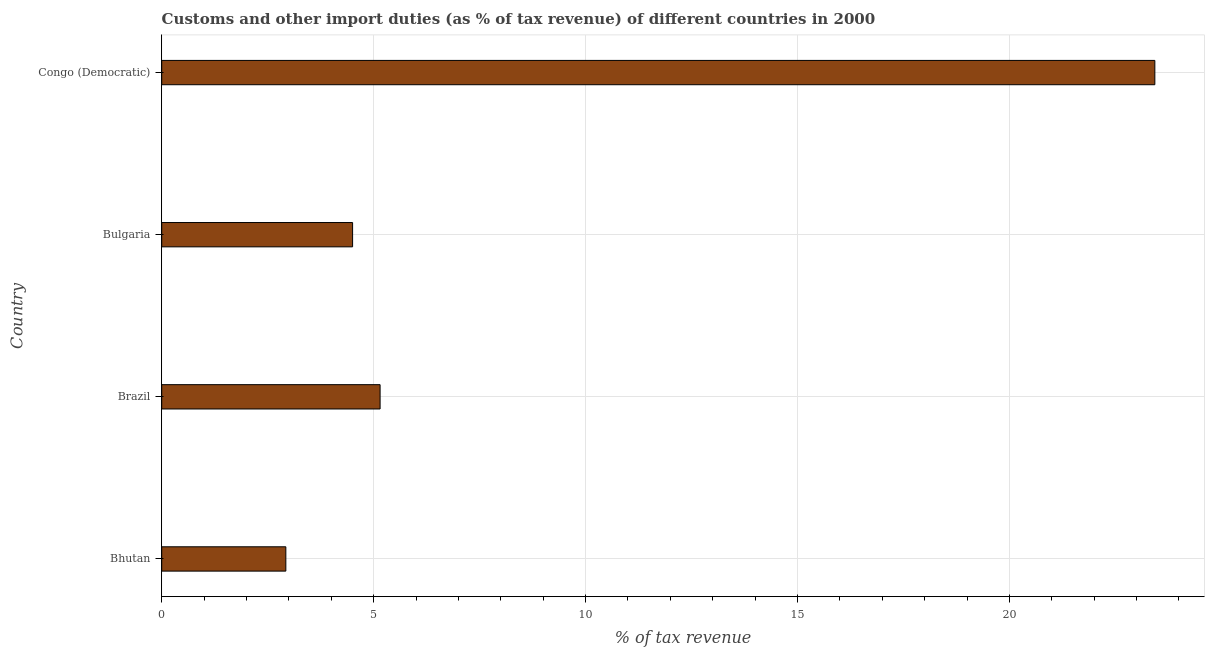Does the graph contain any zero values?
Offer a terse response. No. What is the title of the graph?
Offer a very short reply. Customs and other import duties (as % of tax revenue) of different countries in 2000. What is the label or title of the X-axis?
Make the answer very short. % of tax revenue. What is the label or title of the Y-axis?
Provide a succinct answer. Country. What is the customs and other import duties in Bhutan?
Provide a short and direct response. 2.93. Across all countries, what is the maximum customs and other import duties?
Your answer should be very brief. 23.43. Across all countries, what is the minimum customs and other import duties?
Offer a terse response. 2.93. In which country was the customs and other import duties maximum?
Provide a short and direct response. Congo (Democratic). In which country was the customs and other import duties minimum?
Keep it short and to the point. Bhutan. What is the sum of the customs and other import duties?
Offer a very short reply. 36.01. What is the difference between the customs and other import duties in Bhutan and Brazil?
Ensure brevity in your answer.  -2.22. What is the average customs and other import duties per country?
Offer a very short reply. 9. What is the median customs and other import duties?
Your answer should be compact. 4.83. In how many countries, is the customs and other import duties greater than 5 %?
Ensure brevity in your answer.  2. What is the ratio of the customs and other import duties in Bhutan to that in Congo (Democratic)?
Keep it short and to the point. 0.12. What is the difference between the highest and the second highest customs and other import duties?
Your answer should be very brief. 18.28. Is the sum of the customs and other import duties in Brazil and Congo (Democratic) greater than the maximum customs and other import duties across all countries?
Provide a succinct answer. Yes. In how many countries, is the customs and other import duties greater than the average customs and other import duties taken over all countries?
Ensure brevity in your answer.  1. How many bars are there?
Your answer should be compact. 4. Are all the bars in the graph horizontal?
Give a very brief answer. Yes. How many countries are there in the graph?
Keep it short and to the point. 4. What is the % of tax revenue in Bhutan?
Ensure brevity in your answer.  2.93. What is the % of tax revenue of Brazil?
Your response must be concise. 5.15. What is the % of tax revenue of Bulgaria?
Give a very brief answer. 4.5. What is the % of tax revenue in Congo (Democratic)?
Ensure brevity in your answer.  23.43. What is the difference between the % of tax revenue in Bhutan and Brazil?
Your response must be concise. -2.22. What is the difference between the % of tax revenue in Bhutan and Bulgaria?
Offer a terse response. -1.57. What is the difference between the % of tax revenue in Bhutan and Congo (Democratic)?
Make the answer very short. -20.5. What is the difference between the % of tax revenue in Brazil and Bulgaria?
Offer a terse response. 0.65. What is the difference between the % of tax revenue in Brazil and Congo (Democratic)?
Your answer should be compact. -18.28. What is the difference between the % of tax revenue in Bulgaria and Congo (Democratic)?
Keep it short and to the point. -18.93. What is the ratio of the % of tax revenue in Bhutan to that in Brazil?
Give a very brief answer. 0.57. What is the ratio of the % of tax revenue in Bhutan to that in Bulgaria?
Offer a terse response. 0.65. What is the ratio of the % of tax revenue in Brazil to that in Bulgaria?
Provide a succinct answer. 1.14. What is the ratio of the % of tax revenue in Brazil to that in Congo (Democratic)?
Keep it short and to the point. 0.22. What is the ratio of the % of tax revenue in Bulgaria to that in Congo (Democratic)?
Give a very brief answer. 0.19. 